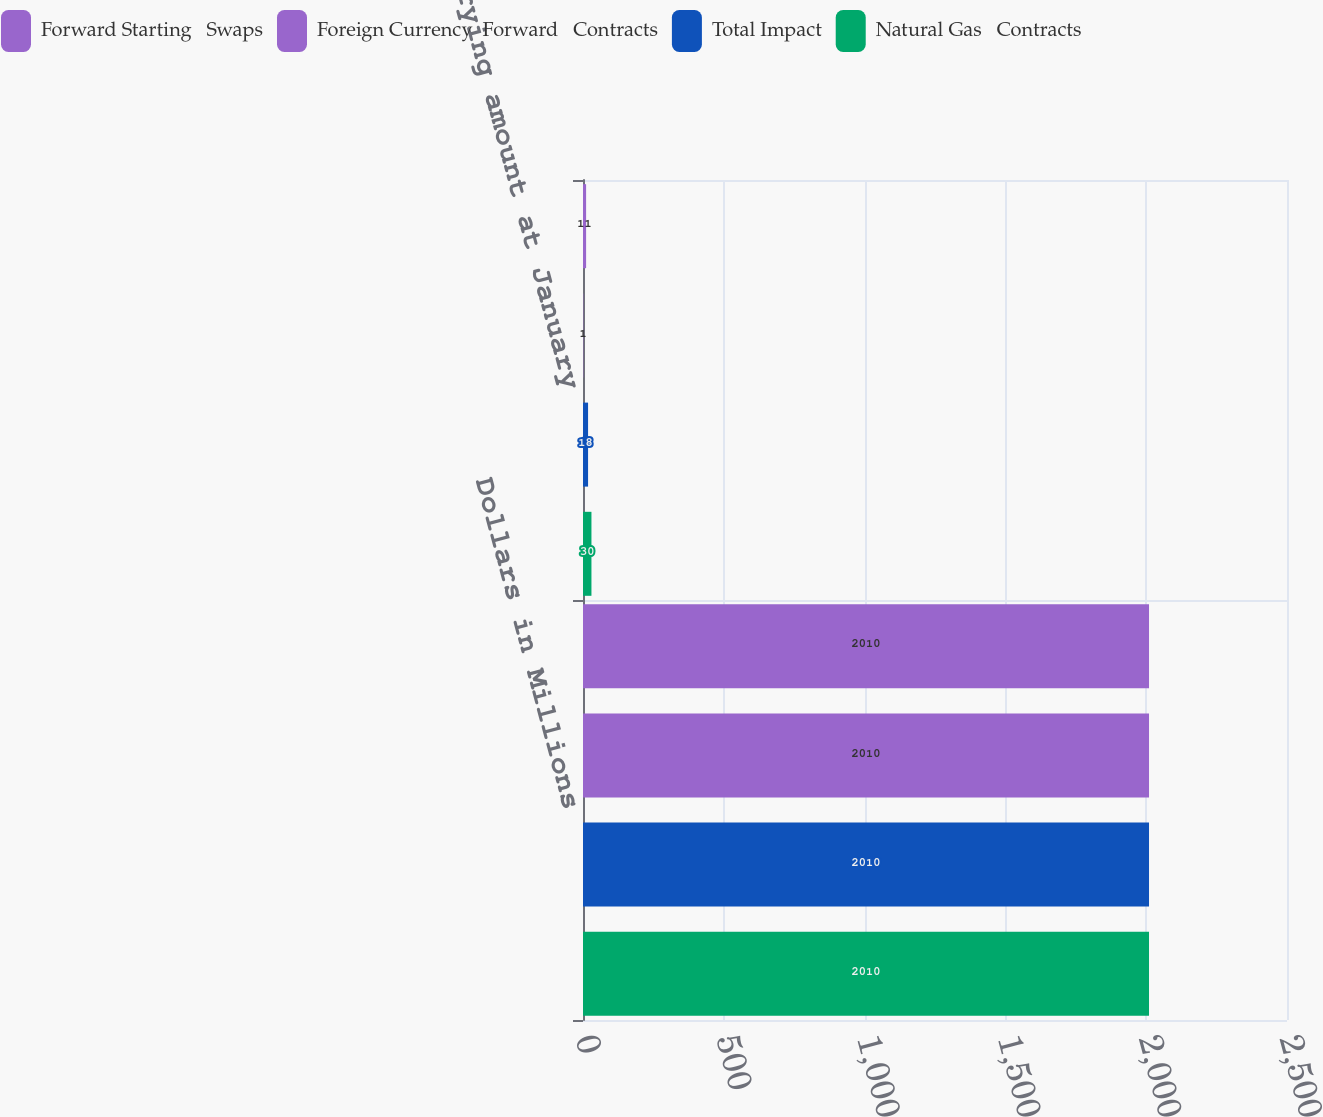<chart> <loc_0><loc_0><loc_500><loc_500><stacked_bar_chart><ecel><fcel>Dollars in Millions<fcel>Net carrying amount at January<nl><fcel>Forward Starting   Swaps<fcel>2010<fcel>11<nl><fcel>Foreign Currency  Forward   Contracts<fcel>2010<fcel>1<nl><fcel>Total Impact<fcel>2010<fcel>18<nl><fcel>Natural Gas   Contracts<fcel>2010<fcel>30<nl></chart> 